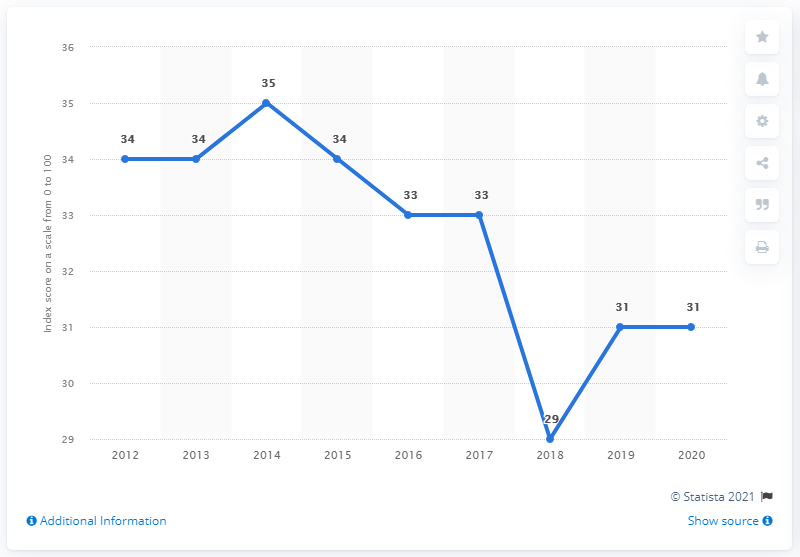Indicate a few pertinent items in this graphic. In 2020, Bolivia's corruption perception index score was 31, indicating a high level of corruption in the country. The mode is 34. In 2018, there was a significant decrease. 